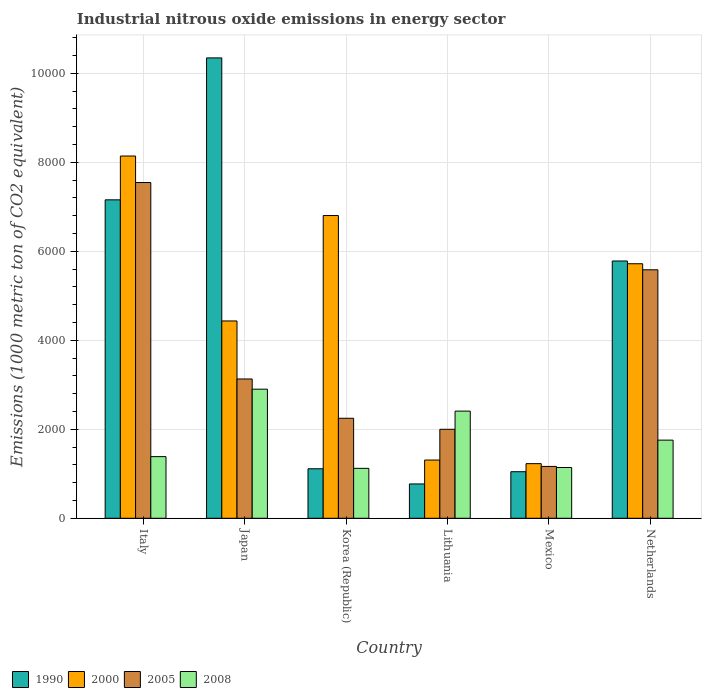How many different coloured bars are there?
Offer a very short reply. 4. Are the number of bars on each tick of the X-axis equal?
Offer a very short reply. Yes. What is the amount of industrial nitrous oxide emitted in 2008 in Japan?
Give a very brief answer. 2901. Across all countries, what is the maximum amount of industrial nitrous oxide emitted in 1990?
Provide a short and direct response. 1.03e+04. Across all countries, what is the minimum amount of industrial nitrous oxide emitted in 1990?
Keep it short and to the point. 771.2. In which country was the amount of industrial nitrous oxide emitted in 1990 minimum?
Your answer should be compact. Lithuania. What is the total amount of industrial nitrous oxide emitted in 2005 in the graph?
Make the answer very short. 2.17e+04. What is the difference between the amount of industrial nitrous oxide emitted in 2005 in Italy and that in Mexico?
Offer a very short reply. 6380.1. What is the difference between the amount of industrial nitrous oxide emitted in 2000 in Lithuania and the amount of industrial nitrous oxide emitted in 2008 in Korea (Republic)?
Offer a very short reply. 186.6. What is the average amount of industrial nitrous oxide emitted in 2000 per country?
Make the answer very short. 4605.48. What is the difference between the amount of industrial nitrous oxide emitted of/in 1990 and amount of industrial nitrous oxide emitted of/in 2005 in Netherlands?
Your answer should be compact. 197.9. What is the ratio of the amount of industrial nitrous oxide emitted in 2005 in Mexico to that in Netherlands?
Make the answer very short. 0.21. Is the amount of industrial nitrous oxide emitted in 2005 in Korea (Republic) less than that in Mexico?
Provide a short and direct response. No. Is the difference between the amount of industrial nitrous oxide emitted in 1990 in Korea (Republic) and Lithuania greater than the difference between the amount of industrial nitrous oxide emitted in 2005 in Korea (Republic) and Lithuania?
Ensure brevity in your answer.  Yes. What is the difference between the highest and the second highest amount of industrial nitrous oxide emitted in 2008?
Provide a succinct answer. 652.3. What is the difference between the highest and the lowest amount of industrial nitrous oxide emitted in 2005?
Your answer should be very brief. 6380.1. Is the sum of the amount of industrial nitrous oxide emitted in 2000 in Mexico and Netherlands greater than the maximum amount of industrial nitrous oxide emitted in 2008 across all countries?
Offer a very short reply. Yes. What is the difference between two consecutive major ticks on the Y-axis?
Provide a short and direct response. 2000. Are the values on the major ticks of Y-axis written in scientific E-notation?
Offer a very short reply. No. Where does the legend appear in the graph?
Keep it short and to the point. Bottom left. How are the legend labels stacked?
Provide a short and direct response. Horizontal. What is the title of the graph?
Make the answer very short. Industrial nitrous oxide emissions in energy sector. What is the label or title of the X-axis?
Your answer should be very brief. Country. What is the label or title of the Y-axis?
Keep it short and to the point. Emissions (1000 metric ton of CO2 equivalent). What is the Emissions (1000 metric ton of CO2 equivalent) in 1990 in Italy?
Ensure brevity in your answer.  7155.8. What is the Emissions (1000 metric ton of CO2 equivalent) in 2000 in Italy?
Offer a terse response. 8140.4. What is the Emissions (1000 metric ton of CO2 equivalent) in 2005 in Italy?
Your response must be concise. 7544.9. What is the Emissions (1000 metric ton of CO2 equivalent) in 2008 in Italy?
Provide a succinct answer. 1385.2. What is the Emissions (1000 metric ton of CO2 equivalent) in 1990 in Japan?
Keep it short and to the point. 1.03e+04. What is the Emissions (1000 metric ton of CO2 equivalent) in 2000 in Japan?
Keep it short and to the point. 4433.9. What is the Emissions (1000 metric ton of CO2 equivalent) in 2005 in Japan?
Keep it short and to the point. 3130.3. What is the Emissions (1000 metric ton of CO2 equivalent) in 2008 in Japan?
Provide a succinct answer. 2901. What is the Emissions (1000 metric ton of CO2 equivalent) of 1990 in Korea (Republic)?
Your response must be concise. 1112.3. What is the Emissions (1000 metric ton of CO2 equivalent) in 2000 in Korea (Republic)?
Your response must be concise. 6803. What is the Emissions (1000 metric ton of CO2 equivalent) of 2005 in Korea (Republic)?
Your answer should be very brief. 2247.5. What is the Emissions (1000 metric ton of CO2 equivalent) in 2008 in Korea (Republic)?
Provide a succinct answer. 1121.9. What is the Emissions (1000 metric ton of CO2 equivalent) of 1990 in Lithuania?
Give a very brief answer. 771.2. What is the Emissions (1000 metric ton of CO2 equivalent) of 2000 in Lithuania?
Make the answer very short. 1308.5. What is the Emissions (1000 metric ton of CO2 equivalent) of 2005 in Lithuania?
Ensure brevity in your answer.  1999.4. What is the Emissions (1000 metric ton of CO2 equivalent) in 2008 in Lithuania?
Provide a succinct answer. 2408. What is the Emissions (1000 metric ton of CO2 equivalent) of 1990 in Mexico?
Offer a very short reply. 1046.3. What is the Emissions (1000 metric ton of CO2 equivalent) in 2000 in Mexico?
Ensure brevity in your answer.  1227.6. What is the Emissions (1000 metric ton of CO2 equivalent) of 2005 in Mexico?
Your answer should be compact. 1164.8. What is the Emissions (1000 metric ton of CO2 equivalent) of 2008 in Mexico?
Your answer should be compact. 1141.1. What is the Emissions (1000 metric ton of CO2 equivalent) in 1990 in Netherlands?
Your answer should be very brief. 5781.5. What is the Emissions (1000 metric ton of CO2 equivalent) of 2000 in Netherlands?
Make the answer very short. 5719.5. What is the Emissions (1000 metric ton of CO2 equivalent) in 2005 in Netherlands?
Provide a short and direct response. 5583.6. What is the Emissions (1000 metric ton of CO2 equivalent) in 2008 in Netherlands?
Keep it short and to the point. 1755.7. Across all countries, what is the maximum Emissions (1000 metric ton of CO2 equivalent) in 1990?
Ensure brevity in your answer.  1.03e+04. Across all countries, what is the maximum Emissions (1000 metric ton of CO2 equivalent) of 2000?
Ensure brevity in your answer.  8140.4. Across all countries, what is the maximum Emissions (1000 metric ton of CO2 equivalent) of 2005?
Offer a terse response. 7544.9. Across all countries, what is the maximum Emissions (1000 metric ton of CO2 equivalent) in 2008?
Make the answer very short. 2901. Across all countries, what is the minimum Emissions (1000 metric ton of CO2 equivalent) in 1990?
Your response must be concise. 771.2. Across all countries, what is the minimum Emissions (1000 metric ton of CO2 equivalent) of 2000?
Provide a short and direct response. 1227.6. Across all countries, what is the minimum Emissions (1000 metric ton of CO2 equivalent) of 2005?
Keep it short and to the point. 1164.8. Across all countries, what is the minimum Emissions (1000 metric ton of CO2 equivalent) of 2008?
Your answer should be compact. 1121.9. What is the total Emissions (1000 metric ton of CO2 equivalent) of 1990 in the graph?
Give a very brief answer. 2.62e+04. What is the total Emissions (1000 metric ton of CO2 equivalent) in 2000 in the graph?
Your response must be concise. 2.76e+04. What is the total Emissions (1000 metric ton of CO2 equivalent) of 2005 in the graph?
Provide a short and direct response. 2.17e+04. What is the total Emissions (1000 metric ton of CO2 equivalent) of 2008 in the graph?
Your answer should be very brief. 1.07e+04. What is the difference between the Emissions (1000 metric ton of CO2 equivalent) in 1990 in Italy and that in Japan?
Ensure brevity in your answer.  -3189.6. What is the difference between the Emissions (1000 metric ton of CO2 equivalent) of 2000 in Italy and that in Japan?
Offer a very short reply. 3706.5. What is the difference between the Emissions (1000 metric ton of CO2 equivalent) of 2005 in Italy and that in Japan?
Your response must be concise. 4414.6. What is the difference between the Emissions (1000 metric ton of CO2 equivalent) in 2008 in Italy and that in Japan?
Your answer should be compact. -1515.8. What is the difference between the Emissions (1000 metric ton of CO2 equivalent) of 1990 in Italy and that in Korea (Republic)?
Your response must be concise. 6043.5. What is the difference between the Emissions (1000 metric ton of CO2 equivalent) in 2000 in Italy and that in Korea (Republic)?
Provide a short and direct response. 1337.4. What is the difference between the Emissions (1000 metric ton of CO2 equivalent) of 2005 in Italy and that in Korea (Republic)?
Your response must be concise. 5297.4. What is the difference between the Emissions (1000 metric ton of CO2 equivalent) of 2008 in Italy and that in Korea (Republic)?
Your answer should be compact. 263.3. What is the difference between the Emissions (1000 metric ton of CO2 equivalent) in 1990 in Italy and that in Lithuania?
Offer a very short reply. 6384.6. What is the difference between the Emissions (1000 metric ton of CO2 equivalent) of 2000 in Italy and that in Lithuania?
Your response must be concise. 6831.9. What is the difference between the Emissions (1000 metric ton of CO2 equivalent) of 2005 in Italy and that in Lithuania?
Offer a very short reply. 5545.5. What is the difference between the Emissions (1000 metric ton of CO2 equivalent) in 2008 in Italy and that in Lithuania?
Give a very brief answer. -1022.8. What is the difference between the Emissions (1000 metric ton of CO2 equivalent) in 1990 in Italy and that in Mexico?
Offer a very short reply. 6109.5. What is the difference between the Emissions (1000 metric ton of CO2 equivalent) in 2000 in Italy and that in Mexico?
Ensure brevity in your answer.  6912.8. What is the difference between the Emissions (1000 metric ton of CO2 equivalent) of 2005 in Italy and that in Mexico?
Your answer should be very brief. 6380.1. What is the difference between the Emissions (1000 metric ton of CO2 equivalent) of 2008 in Italy and that in Mexico?
Offer a terse response. 244.1. What is the difference between the Emissions (1000 metric ton of CO2 equivalent) in 1990 in Italy and that in Netherlands?
Make the answer very short. 1374.3. What is the difference between the Emissions (1000 metric ton of CO2 equivalent) in 2000 in Italy and that in Netherlands?
Your answer should be very brief. 2420.9. What is the difference between the Emissions (1000 metric ton of CO2 equivalent) in 2005 in Italy and that in Netherlands?
Keep it short and to the point. 1961.3. What is the difference between the Emissions (1000 metric ton of CO2 equivalent) of 2008 in Italy and that in Netherlands?
Provide a succinct answer. -370.5. What is the difference between the Emissions (1000 metric ton of CO2 equivalent) of 1990 in Japan and that in Korea (Republic)?
Your response must be concise. 9233.1. What is the difference between the Emissions (1000 metric ton of CO2 equivalent) in 2000 in Japan and that in Korea (Republic)?
Keep it short and to the point. -2369.1. What is the difference between the Emissions (1000 metric ton of CO2 equivalent) of 2005 in Japan and that in Korea (Republic)?
Provide a succinct answer. 882.8. What is the difference between the Emissions (1000 metric ton of CO2 equivalent) of 2008 in Japan and that in Korea (Republic)?
Your answer should be very brief. 1779.1. What is the difference between the Emissions (1000 metric ton of CO2 equivalent) in 1990 in Japan and that in Lithuania?
Your response must be concise. 9574.2. What is the difference between the Emissions (1000 metric ton of CO2 equivalent) in 2000 in Japan and that in Lithuania?
Provide a short and direct response. 3125.4. What is the difference between the Emissions (1000 metric ton of CO2 equivalent) of 2005 in Japan and that in Lithuania?
Keep it short and to the point. 1130.9. What is the difference between the Emissions (1000 metric ton of CO2 equivalent) of 2008 in Japan and that in Lithuania?
Keep it short and to the point. 493. What is the difference between the Emissions (1000 metric ton of CO2 equivalent) in 1990 in Japan and that in Mexico?
Offer a terse response. 9299.1. What is the difference between the Emissions (1000 metric ton of CO2 equivalent) of 2000 in Japan and that in Mexico?
Your answer should be very brief. 3206.3. What is the difference between the Emissions (1000 metric ton of CO2 equivalent) of 2005 in Japan and that in Mexico?
Ensure brevity in your answer.  1965.5. What is the difference between the Emissions (1000 metric ton of CO2 equivalent) of 2008 in Japan and that in Mexico?
Offer a very short reply. 1759.9. What is the difference between the Emissions (1000 metric ton of CO2 equivalent) in 1990 in Japan and that in Netherlands?
Keep it short and to the point. 4563.9. What is the difference between the Emissions (1000 metric ton of CO2 equivalent) in 2000 in Japan and that in Netherlands?
Offer a very short reply. -1285.6. What is the difference between the Emissions (1000 metric ton of CO2 equivalent) in 2005 in Japan and that in Netherlands?
Provide a short and direct response. -2453.3. What is the difference between the Emissions (1000 metric ton of CO2 equivalent) in 2008 in Japan and that in Netherlands?
Keep it short and to the point. 1145.3. What is the difference between the Emissions (1000 metric ton of CO2 equivalent) in 1990 in Korea (Republic) and that in Lithuania?
Your response must be concise. 341.1. What is the difference between the Emissions (1000 metric ton of CO2 equivalent) of 2000 in Korea (Republic) and that in Lithuania?
Your response must be concise. 5494.5. What is the difference between the Emissions (1000 metric ton of CO2 equivalent) of 2005 in Korea (Republic) and that in Lithuania?
Offer a terse response. 248.1. What is the difference between the Emissions (1000 metric ton of CO2 equivalent) of 2008 in Korea (Republic) and that in Lithuania?
Offer a very short reply. -1286.1. What is the difference between the Emissions (1000 metric ton of CO2 equivalent) of 1990 in Korea (Republic) and that in Mexico?
Give a very brief answer. 66. What is the difference between the Emissions (1000 metric ton of CO2 equivalent) in 2000 in Korea (Republic) and that in Mexico?
Give a very brief answer. 5575.4. What is the difference between the Emissions (1000 metric ton of CO2 equivalent) of 2005 in Korea (Republic) and that in Mexico?
Your answer should be very brief. 1082.7. What is the difference between the Emissions (1000 metric ton of CO2 equivalent) of 2008 in Korea (Republic) and that in Mexico?
Offer a terse response. -19.2. What is the difference between the Emissions (1000 metric ton of CO2 equivalent) in 1990 in Korea (Republic) and that in Netherlands?
Make the answer very short. -4669.2. What is the difference between the Emissions (1000 metric ton of CO2 equivalent) in 2000 in Korea (Republic) and that in Netherlands?
Your answer should be very brief. 1083.5. What is the difference between the Emissions (1000 metric ton of CO2 equivalent) of 2005 in Korea (Republic) and that in Netherlands?
Your response must be concise. -3336.1. What is the difference between the Emissions (1000 metric ton of CO2 equivalent) in 2008 in Korea (Republic) and that in Netherlands?
Offer a very short reply. -633.8. What is the difference between the Emissions (1000 metric ton of CO2 equivalent) in 1990 in Lithuania and that in Mexico?
Your response must be concise. -275.1. What is the difference between the Emissions (1000 metric ton of CO2 equivalent) in 2000 in Lithuania and that in Mexico?
Make the answer very short. 80.9. What is the difference between the Emissions (1000 metric ton of CO2 equivalent) in 2005 in Lithuania and that in Mexico?
Offer a terse response. 834.6. What is the difference between the Emissions (1000 metric ton of CO2 equivalent) in 2008 in Lithuania and that in Mexico?
Offer a terse response. 1266.9. What is the difference between the Emissions (1000 metric ton of CO2 equivalent) in 1990 in Lithuania and that in Netherlands?
Make the answer very short. -5010.3. What is the difference between the Emissions (1000 metric ton of CO2 equivalent) of 2000 in Lithuania and that in Netherlands?
Keep it short and to the point. -4411. What is the difference between the Emissions (1000 metric ton of CO2 equivalent) of 2005 in Lithuania and that in Netherlands?
Your answer should be very brief. -3584.2. What is the difference between the Emissions (1000 metric ton of CO2 equivalent) of 2008 in Lithuania and that in Netherlands?
Keep it short and to the point. 652.3. What is the difference between the Emissions (1000 metric ton of CO2 equivalent) in 1990 in Mexico and that in Netherlands?
Offer a very short reply. -4735.2. What is the difference between the Emissions (1000 metric ton of CO2 equivalent) in 2000 in Mexico and that in Netherlands?
Provide a short and direct response. -4491.9. What is the difference between the Emissions (1000 metric ton of CO2 equivalent) of 2005 in Mexico and that in Netherlands?
Provide a succinct answer. -4418.8. What is the difference between the Emissions (1000 metric ton of CO2 equivalent) of 2008 in Mexico and that in Netherlands?
Provide a short and direct response. -614.6. What is the difference between the Emissions (1000 metric ton of CO2 equivalent) in 1990 in Italy and the Emissions (1000 metric ton of CO2 equivalent) in 2000 in Japan?
Your response must be concise. 2721.9. What is the difference between the Emissions (1000 metric ton of CO2 equivalent) of 1990 in Italy and the Emissions (1000 metric ton of CO2 equivalent) of 2005 in Japan?
Give a very brief answer. 4025.5. What is the difference between the Emissions (1000 metric ton of CO2 equivalent) of 1990 in Italy and the Emissions (1000 metric ton of CO2 equivalent) of 2008 in Japan?
Provide a succinct answer. 4254.8. What is the difference between the Emissions (1000 metric ton of CO2 equivalent) in 2000 in Italy and the Emissions (1000 metric ton of CO2 equivalent) in 2005 in Japan?
Make the answer very short. 5010.1. What is the difference between the Emissions (1000 metric ton of CO2 equivalent) of 2000 in Italy and the Emissions (1000 metric ton of CO2 equivalent) of 2008 in Japan?
Offer a very short reply. 5239.4. What is the difference between the Emissions (1000 metric ton of CO2 equivalent) of 2005 in Italy and the Emissions (1000 metric ton of CO2 equivalent) of 2008 in Japan?
Offer a terse response. 4643.9. What is the difference between the Emissions (1000 metric ton of CO2 equivalent) in 1990 in Italy and the Emissions (1000 metric ton of CO2 equivalent) in 2000 in Korea (Republic)?
Offer a very short reply. 352.8. What is the difference between the Emissions (1000 metric ton of CO2 equivalent) in 1990 in Italy and the Emissions (1000 metric ton of CO2 equivalent) in 2005 in Korea (Republic)?
Keep it short and to the point. 4908.3. What is the difference between the Emissions (1000 metric ton of CO2 equivalent) in 1990 in Italy and the Emissions (1000 metric ton of CO2 equivalent) in 2008 in Korea (Republic)?
Give a very brief answer. 6033.9. What is the difference between the Emissions (1000 metric ton of CO2 equivalent) of 2000 in Italy and the Emissions (1000 metric ton of CO2 equivalent) of 2005 in Korea (Republic)?
Your answer should be very brief. 5892.9. What is the difference between the Emissions (1000 metric ton of CO2 equivalent) in 2000 in Italy and the Emissions (1000 metric ton of CO2 equivalent) in 2008 in Korea (Republic)?
Offer a very short reply. 7018.5. What is the difference between the Emissions (1000 metric ton of CO2 equivalent) of 2005 in Italy and the Emissions (1000 metric ton of CO2 equivalent) of 2008 in Korea (Republic)?
Provide a short and direct response. 6423. What is the difference between the Emissions (1000 metric ton of CO2 equivalent) in 1990 in Italy and the Emissions (1000 metric ton of CO2 equivalent) in 2000 in Lithuania?
Offer a very short reply. 5847.3. What is the difference between the Emissions (1000 metric ton of CO2 equivalent) in 1990 in Italy and the Emissions (1000 metric ton of CO2 equivalent) in 2005 in Lithuania?
Make the answer very short. 5156.4. What is the difference between the Emissions (1000 metric ton of CO2 equivalent) in 1990 in Italy and the Emissions (1000 metric ton of CO2 equivalent) in 2008 in Lithuania?
Keep it short and to the point. 4747.8. What is the difference between the Emissions (1000 metric ton of CO2 equivalent) of 2000 in Italy and the Emissions (1000 metric ton of CO2 equivalent) of 2005 in Lithuania?
Provide a succinct answer. 6141. What is the difference between the Emissions (1000 metric ton of CO2 equivalent) of 2000 in Italy and the Emissions (1000 metric ton of CO2 equivalent) of 2008 in Lithuania?
Provide a succinct answer. 5732.4. What is the difference between the Emissions (1000 metric ton of CO2 equivalent) in 2005 in Italy and the Emissions (1000 metric ton of CO2 equivalent) in 2008 in Lithuania?
Give a very brief answer. 5136.9. What is the difference between the Emissions (1000 metric ton of CO2 equivalent) in 1990 in Italy and the Emissions (1000 metric ton of CO2 equivalent) in 2000 in Mexico?
Your response must be concise. 5928.2. What is the difference between the Emissions (1000 metric ton of CO2 equivalent) in 1990 in Italy and the Emissions (1000 metric ton of CO2 equivalent) in 2005 in Mexico?
Keep it short and to the point. 5991. What is the difference between the Emissions (1000 metric ton of CO2 equivalent) of 1990 in Italy and the Emissions (1000 metric ton of CO2 equivalent) of 2008 in Mexico?
Your answer should be compact. 6014.7. What is the difference between the Emissions (1000 metric ton of CO2 equivalent) in 2000 in Italy and the Emissions (1000 metric ton of CO2 equivalent) in 2005 in Mexico?
Give a very brief answer. 6975.6. What is the difference between the Emissions (1000 metric ton of CO2 equivalent) in 2000 in Italy and the Emissions (1000 metric ton of CO2 equivalent) in 2008 in Mexico?
Your answer should be compact. 6999.3. What is the difference between the Emissions (1000 metric ton of CO2 equivalent) in 2005 in Italy and the Emissions (1000 metric ton of CO2 equivalent) in 2008 in Mexico?
Your response must be concise. 6403.8. What is the difference between the Emissions (1000 metric ton of CO2 equivalent) in 1990 in Italy and the Emissions (1000 metric ton of CO2 equivalent) in 2000 in Netherlands?
Keep it short and to the point. 1436.3. What is the difference between the Emissions (1000 metric ton of CO2 equivalent) of 1990 in Italy and the Emissions (1000 metric ton of CO2 equivalent) of 2005 in Netherlands?
Ensure brevity in your answer.  1572.2. What is the difference between the Emissions (1000 metric ton of CO2 equivalent) of 1990 in Italy and the Emissions (1000 metric ton of CO2 equivalent) of 2008 in Netherlands?
Provide a succinct answer. 5400.1. What is the difference between the Emissions (1000 metric ton of CO2 equivalent) in 2000 in Italy and the Emissions (1000 metric ton of CO2 equivalent) in 2005 in Netherlands?
Make the answer very short. 2556.8. What is the difference between the Emissions (1000 metric ton of CO2 equivalent) in 2000 in Italy and the Emissions (1000 metric ton of CO2 equivalent) in 2008 in Netherlands?
Your response must be concise. 6384.7. What is the difference between the Emissions (1000 metric ton of CO2 equivalent) of 2005 in Italy and the Emissions (1000 metric ton of CO2 equivalent) of 2008 in Netherlands?
Ensure brevity in your answer.  5789.2. What is the difference between the Emissions (1000 metric ton of CO2 equivalent) in 1990 in Japan and the Emissions (1000 metric ton of CO2 equivalent) in 2000 in Korea (Republic)?
Give a very brief answer. 3542.4. What is the difference between the Emissions (1000 metric ton of CO2 equivalent) in 1990 in Japan and the Emissions (1000 metric ton of CO2 equivalent) in 2005 in Korea (Republic)?
Provide a succinct answer. 8097.9. What is the difference between the Emissions (1000 metric ton of CO2 equivalent) of 1990 in Japan and the Emissions (1000 metric ton of CO2 equivalent) of 2008 in Korea (Republic)?
Make the answer very short. 9223.5. What is the difference between the Emissions (1000 metric ton of CO2 equivalent) in 2000 in Japan and the Emissions (1000 metric ton of CO2 equivalent) in 2005 in Korea (Republic)?
Offer a terse response. 2186.4. What is the difference between the Emissions (1000 metric ton of CO2 equivalent) of 2000 in Japan and the Emissions (1000 metric ton of CO2 equivalent) of 2008 in Korea (Republic)?
Give a very brief answer. 3312. What is the difference between the Emissions (1000 metric ton of CO2 equivalent) of 2005 in Japan and the Emissions (1000 metric ton of CO2 equivalent) of 2008 in Korea (Republic)?
Provide a succinct answer. 2008.4. What is the difference between the Emissions (1000 metric ton of CO2 equivalent) of 1990 in Japan and the Emissions (1000 metric ton of CO2 equivalent) of 2000 in Lithuania?
Your answer should be compact. 9036.9. What is the difference between the Emissions (1000 metric ton of CO2 equivalent) in 1990 in Japan and the Emissions (1000 metric ton of CO2 equivalent) in 2005 in Lithuania?
Ensure brevity in your answer.  8346. What is the difference between the Emissions (1000 metric ton of CO2 equivalent) in 1990 in Japan and the Emissions (1000 metric ton of CO2 equivalent) in 2008 in Lithuania?
Your answer should be compact. 7937.4. What is the difference between the Emissions (1000 metric ton of CO2 equivalent) of 2000 in Japan and the Emissions (1000 metric ton of CO2 equivalent) of 2005 in Lithuania?
Your response must be concise. 2434.5. What is the difference between the Emissions (1000 metric ton of CO2 equivalent) in 2000 in Japan and the Emissions (1000 metric ton of CO2 equivalent) in 2008 in Lithuania?
Provide a short and direct response. 2025.9. What is the difference between the Emissions (1000 metric ton of CO2 equivalent) in 2005 in Japan and the Emissions (1000 metric ton of CO2 equivalent) in 2008 in Lithuania?
Provide a short and direct response. 722.3. What is the difference between the Emissions (1000 metric ton of CO2 equivalent) of 1990 in Japan and the Emissions (1000 metric ton of CO2 equivalent) of 2000 in Mexico?
Provide a short and direct response. 9117.8. What is the difference between the Emissions (1000 metric ton of CO2 equivalent) of 1990 in Japan and the Emissions (1000 metric ton of CO2 equivalent) of 2005 in Mexico?
Your answer should be compact. 9180.6. What is the difference between the Emissions (1000 metric ton of CO2 equivalent) in 1990 in Japan and the Emissions (1000 metric ton of CO2 equivalent) in 2008 in Mexico?
Offer a terse response. 9204.3. What is the difference between the Emissions (1000 metric ton of CO2 equivalent) in 2000 in Japan and the Emissions (1000 metric ton of CO2 equivalent) in 2005 in Mexico?
Make the answer very short. 3269.1. What is the difference between the Emissions (1000 metric ton of CO2 equivalent) in 2000 in Japan and the Emissions (1000 metric ton of CO2 equivalent) in 2008 in Mexico?
Make the answer very short. 3292.8. What is the difference between the Emissions (1000 metric ton of CO2 equivalent) of 2005 in Japan and the Emissions (1000 metric ton of CO2 equivalent) of 2008 in Mexico?
Your answer should be very brief. 1989.2. What is the difference between the Emissions (1000 metric ton of CO2 equivalent) of 1990 in Japan and the Emissions (1000 metric ton of CO2 equivalent) of 2000 in Netherlands?
Your answer should be compact. 4625.9. What is the difference between the Emissions (1000 metric ton of CO2 equivalent) of 1990 in Japan and the Emissions (1000 metric ton of CO2 equivalent) of 2005 in Netherlands?
Provide a succinct answer. 4761.8. What is the difference between the Emissions (1000 metric ton of CO2 equivalent) of 1990 in Japan and the Emissions (1000 metric ton of CO2 equivalent) of 2008 in Netherlands?
Provide a short and direct response. 8589.7. What is the difference between the Emissions (1000 metric ton of CO2 equivalent) in 2000 in Japan and the Emissions (1000 metric ton of CO2 equivalent) in 2005 in Netherlands?
Provide a succinct answer. -1149.7. What is the difference between the Emissions (1000 metric ton of CO2 equivalent) of 2000 in Japan and the Emissions (1000 metric ton of CO2 equivalent) of 2008 in Netherlands?
Keep it short and to the point. 2678.2. What is the difference between the Emissions (1000 metric ton of CO2 equivalent) in 2005 in Japan and the Emissions (1000 metric ton of CO2 equivalent) in 2008 in Netherlands?
Provide a short and direct response. 1374.6. What is the difference between the Emissions (1000 metric ton of CO2 equivalent) in 1990 in Korea (Republic) and the Emissions (1000 metric ton of CO2 equivalent) in 2000 in Lithuania?
Make the answer very short. -196.2. What is the difference between the Emissions (1000 metric ton of CO2 equivalent) in 1990 in Korea (Republic) and the Emissions (1000 metric ton of CO2 equivalent) in 2005 in Lithuania?
Make the answer very short. -887.1. What is the difference between the Emissions (1000 metric ton of CO2 equivalent) of 1990 in Korea (Republic) and the Emissions (1000 metric ton of CO2 equivalent) of 2008 in Lithuania?
Offer a terse response. -1295.7. What is the difference between the Emissions (1000 metric ton of CO2 equivalent) of 2000 in Korea (Republic) and the Emissions (1000 metric ton of CO2 equivalent) of 2005 in Lithuania?
Offer a terse response. 4803.6. What is the difference between the Emissions (1000 metric ton of CO2 equivalent) of 2000 in Korea (Republic) and the Emissions (1000 metric ton of CO2 equivalent) of 2008 in Lithuania?
Provide a succinct answer. 4395. What is the difference between the Emissions (1000 metric ton of CO2 equivalent) of 2005 in Korea (Republic) and the Emissions (1000 metric ton of CO2 equivalent) of 2008 in Lithuania?
Your response must be concise. -160.5. What is the difference between the Emissions (1000 metric ton of CO2 equivalent) in 1990 in Korea (Republic) and the Emissions (1000 metric ton of CO2 equivalent) in 2000 in Mexico?
Offer a terse response. -115.3. What is the difference between the Emissions (1000 metric ton of CO2 equivalent) in 1990 in Korea (Republic) and the Emissions (1000 metric ton of CO2 equivalent) in 2005 in Mexico?
Offer a very short reply. -52.5. What is the difference between the Emissions (1000 metric ton of CO2 equivalent) in 1990 in Korea (Republic) and the Emissions (1000 metric ton of CO2 equivalent) in 2008 in Mexico?
Your answer should be compact. -28.8. What is the difference between the Emissions (1000 metric ton of CO2 equivalent) of 2000 in Korea (Republic) and the Emissions (1000 metric ton of CO2 equivalent) of 2005 in Mexico?
Your answer should be very brief. 5638.2. What is the difference between the Emissions (1000 metric ton of CO2 equivalent) of 2000 in Korea (Republic) and the Emissions (1000 metric ton of CO2 equivalent) of 2008 in Mexico?
Your answer should be compact. 5661.9. What is the difference between the Emissions (1000 metric ton of CO2 equivalent) in 2005 in Korea (Republic) and the Emissions (1000 metric ton of CO2 equivalent) in 2008 in Mexico?
Ensure brevity in your answer.  1106.4. What is the difference between the Emissions (1000 metric ton of CO2 equivalent) of 1990 in Korea (Republic) and the Emissions (1000 metric ton of CO2 equivalent) of 2000 in Netherlands?
Your response must be concise. -4607.2. What is the difference between the Emissions (1000 metric ton of CO2 equivalent) of 1990 in Korea (Republic) and the Emissions (1000 metric ton of CO2 equivalent) of 2005 in Netherlands?
Provide a short and direct response. -4471.3. What is the difference between the Emissions (1000 metric ton of CO2 equivalent) in 1990 in Korea (Republic) and the Emissions (1000 metric ton of CO2 equivalent) in 2008 in Netherlands?
Your answer should be compact. -643.4. What is the difference between the Emissions (1000 metric ton of CO2 equivalent) of 2000 in Korea (Republic) and the Emissions (1000 metric ton of CO2 equivalent) of 2005 in Netherlands?
Give a very brief answer. 1219.4. What is the difference between the Emissions (1000 metric ton of CO2 equivalent) of 2000 in Korea (Republic) and the Emissions (1000 metric ton of CO2 equivalent) of 2008 in Netherlands?
Your answer should be compact. 5047.3. What is the difference between the Emissions (1000 metric ton of CO2 equivalent) of 2005 in Korea (Republic) and the Emissions (1000 metric ton of CO2 equivalent) of 2008 in Netherlands?
Ensure brevity in your answer.  491.8. What is the difference between the Emissions (1000 metric ton of CO2 equivalent) of 1990 in Lithuania and the Emissions (1000 metric ton of CO2 equivalent) of 2000 in Mexico?
Ensure brevity in your answer.  -456.4. What is the difference between the Emissions (1000 metric ton of CO2 equivalent) of 1990 in Lithuania and the Emissions (1000 metric ton of CO2 equivalent) of 2005 in Mexico?
Offer a terse response. -393.6. What is the difference between the Emissions (1000 metric ton of CO2 equivalent) in 1990 in Lithuania and the Emissions (1000 metric ton of CO2 equivalent) in 2008 in Mexico?
Your answer should be compact. -369.9. What is the difference between the Emissions (1000 metric ton of CO2 equivalent) of 2000 in Lithuania and the Emissions (1000 metric ton of CO2 equivalent) of 2005 in Mexico?
Make the answer very short. 143.7. What is the difference between the Emissions (1000 metric ton of CO2 equivalent) of 2000 in Lithuania and the Emissions (1000 metric ton of CO2 equivalent) of 2008 in Mexico?
Offer a very short reply. 167.4. What is the difference between the Emissions (1000 metric ton of CO2 equivalent) in 2005 in Lithuania and the Emissions (1000 metric ton of CO2 equivalent) in 2008 in Mexico?
Your answer should be very brief. 858.3. What is the difference between the Emissions (1000 metric ton of CO2 equivalent) in 1990 in Lithuania and the Emissions (1000 metric ton of CO2 equivalent) in 2000 in Netherlands?
Your answer should be very brief. -4948.3. What is the difference between the Emissions (1000 metric ton of CO2 equivalent) in 1990 in Lithuania and the Emissions (1000 metric ton of CO2 equivalent) in 2005 in Netherlands?
Your response must be concise. -4812.4. What is the difference between the Emissions (1000 metric ton of CO2 equivalent) of 1990 in Lithuania and the Emissions (1000 metric ton of CO2 equivalent) of 2008 in Netherlands?
Offer a terse response. -984.5. What is the difference between the Emissions (1000 metric ton of CO2 equivalent) of 2000 in Lithuania and the Emissions (1000 metric ton of CO2 equivalent) of 2005 in Netherlands?
Give a very brief answer. -4275.1. What is the difference between the Emissions (1000 metric ton of CO2 equivalent) in 2000 in Lithuania and the Emissions (1000 metric ton of CO2 equivalent) in 2008 in Netherlands?
Your answer should be compact. -447.2. What is the difference between the Emissions (1000 metric ton of CO2 equivalent) of 2005 in Lithuania and the Emissions (1000 metric ton of CO2 equivalent) of 2008 in Netherlands?
Your answer should be compact. 243.7. What is the difference between the Emissions (1000 metric ton of CO2 equivalent) of 1990 in Mexico and the Emissions (1000 metric ton of CO2 equivalent) of 2000 in Netherlands?
Your answer should be compact. -4673.2. What is the difference between the Emissions (1000 metric ton of CO2 equivalent) in 1990 in Mexico and the Emissions (1000 metric ton of CO2 equivalent) in 2005 in Netherlands?
Provide a short and direct response. -4537.3. What is the difference between the Emissions (1000 metric ton of CO2 equivalent) of 1990 in Mexico and the Emissions (1000 metric ton of CO2 equivalent) of 2008 in Netherlands?
Make the answer very short. -709.4. What is the difference between the Emissions (1000 metric ton of CO2 equivalent) of 2000 in Mexico and the Emissions (1000 metric ton of CO2 equivalent) of 2005 in Netherlands?
Keep it short and to the point. -4356. What is the difference between the Emissions (1000 metric ton of CO2 equivalent) of 2000 in Mexico and the Emissions (1000 metric ton of CO2 equivalent) of 2008 in Netherlands?
Keep it short and to the point. -528.1. What is the difference between the Emissions (1000 metric ton of CO2 equivalent) of 2005 in Mexico and the Emissions (1000 metric ton of CO2 equivalent) of 2008 in Netherlands?
Your response must be concise. -590.9. What is the average Emissions (1000 metric ton of CO2 equivalent) in 1990 per country?
Provide a succinct answer. 4368.75. What is the average Emissions (1000 metric ton of CO2 equivalent) in 2000 per country?
Your answer should be very brief. 4605.48. What is the average Emissions (1000 metric ton of CO2 equivalent) of 2005 per country?
Your answer should be very brief. 3611.75. What is the average Emissions (1000 metric ton of CO2 equivalent) of 2008 per country?
Make the answer very short. 1785.48. What is the difference between the Emissions (1000 metric ton of CO2 equivalent) of 1990 and Emissions (1000 metric ton of CO2 equivalent) of 2000 in Italy?
Give a very brief answer. -984.6. What is the difference between the Emissions (1000 metric ton of CO2 equivalent) in 1990 and Emissions (1000 metric ton of CO2 equivalent) in 2005 in Italy?
Your answer should be compact. -389.1. What is the difference between the Emissions (1000 metric ton of CO2 equivalent) in 1990 and Emissions (1000 metric ton of CO2 equivalent) in 2008 in Italy?
Your answer should be very brief. 5770.6. What is the difference between the Emissions (1000 metric ton of CO2 equivalent) in 2000 and Emissions (1000 metric ton of CO2 equivalent) in 2005 in Italy?
Provide a succinct answer. 595.5. What is the difference between the Emissions (1000 metric ton of CO2 equivalent) of 2000 and Emissions (1000 metric ton of CO2 equivalent) of 2008 in Italy?
Your answer should be compact. 6755.2. What is the difference between the Emissions (1000 metric ton of CO2 equivalent) in 2005 and Emissions (1000 metric ton of CO2 equivalent) in 2008 in Italy?
Provide a short and direct response. 6159.7. What is the difference between the Emissions (1000 metric ton of CO2 equivalent) of 1990 and Emissions (1000 metric ton of CO2 equivalent) of 2000 in Japan?
Your answer should be compact. 5911.5. What is the difference between the Emissions (1000 metric ton of CO2 equivalent) of 1990 and Emissions (1000 metric ton of CO2 equivalent) of 2005 in Japan?
Your response must be concise. 7215.1. What is the difference between the Emissions (1000 metric ton of CO2 equivalent) in 1990 and Emissions (1000 metric ton of CO2 equivalent) in 2008 in Japan?
Offer a terse response. 7444.4. What is the difference between the Emissions (1000 metric ton of CO2 equivalent) of 2000 and Emissions (1000 metric ton of CO2 equivalent) of 2005 in Japan?
Offer a terse response. 1303.6. What is the difference between the Emissions (1000 metric ton of CO2 equivalent) in 2000 and Emissions (1000 metric ton of CO2 equivalent) in 2008 in Japan?
Provide a short and direct response. 1532.9. What is the difference between the Emissions (1000 metric ton of CO2 equivalent) of 2005 and Emissions (1000 metric ton of CO2 equivalent) of 2008 in Japan?
Make the answer very short. 229.3. What is the difference between the Emissions (1000 metric ton of CO2 equivalent) of 1990 and Emissions (1000 metric ton of CO2 equivalent) of 2000 in Korea (Republic)?
Give a very brief answer. -5690.7. What is the difference between the Emissions (1000 metric ton of CO2 equivalent) of 1990 and Emissions (1000 metric ton of CO2 equivalent) of 2005 in Korea (Republic)?
Offer a very short reply. -1135.2. What is the difference between the Emissions (1000 metric ton of CO2 equivalent) of 1990 and Emissions (1000 metric ton of CO2 equivalent) of 2008 in Korea (Republic)?
Keep it short and to the point. -9.6. What is the difference between the Emissions (1000 metric ton of CO2 equivalent) of 2000 and Emissions (1000 metric ton of CO2 equivalent) of 2005 in Korea (Republic)?
Your response must be concise. 4555.5. What is the difference between the Emissions (1000 metric ton of CO2 equivalent) in 2000 and Emissions (1000 metric ton of CO2 equivalent) in 2008 in Korea (Republic)?
Your response must be concise. 5681.1. What is the difference between the Emissions (1000 metric ton of CO2 equivalent) of 2005 and Emissions (1000 metric ton of CO2 equivalent) of 2008 in Korea (Republic)?
Provide a succinct answer. 1125.6. What is the difference between the Emissions (1000 metric ton of CO2 equivalent) of 1990 and Emissions (1000 metric ton of CO2 equivalent) of 2000 in Lithuania?
Your response must be concise. -537.3. What is the difference between the Emissions (1000 metric ton of CO2 equivalent) in 1990 and Emissions (1000 metric ton of CO2 equivalent) in 2005 in Lithuania?
Make the answer very short. -1228.2. What is the difference between the Emissions (1000 metric ton of CO2 equivalent) of 1990 and Emissions (1000 metric ton of CO2 equivalent) of 2008 in Lithuania?
Your response must be concise. -1636.8. What is the difference between the Emissions (1000 metric ton of CO2 equivalent) of 2000 and Emissions (1000 metric ton of CO2 equivalent) of 2005 in Lithuania?
Your response must be concise. -690.9. What is the difference between the Emissions (1000 metric ton of CO2 equivalent) in 2000 and Emissions (1000 metric ton of CO2 equivalent) in 2008 in Lithuania?
Your answer should be very brief. -1099.5. What is the difference between the Emissions (1000 metric ton of CO2 equivalent) in 2005 and Emissions (1000 metric ton of CO2 equivalent) in 2008 in Lithuania?
Offer a terse response. -408.6. What is the difference between the Emissions (1000 metric ton of CO2 equivalent) in 1990 and Emissions (1000 metric ton of CO2 equivalent) in 2000 in Mexico?
Offer a very short reply. -181.3. What is the difference between the Emissions (1000 metric ton of CO2 equivalent) in 1990 and Emissions (1000 metric ton of CO2 equivalent) in 2005 in Mexico?
Your response must be concise. -118.5. What is the difference between the Emissions (1000 metric ton of CO2 equivalent) of 1990 and Emissions (1000 metric ton of CO2 equivalent) of 2008 in Mexico?
Provide a short and direct response. -94.8. What is the difference between the Emissions (1000 metric ton of CO2 equivalent) in 2000 and Emissions (1000 metric ton of CO2 equivalent) in 2005 in Mexico?
Keep it short and to the point. 62.8. What is the difference between the Emissions (1000 metric ton of CO2 equivalent) of 2000 and Emissions (1000 metric ton of CO2 equivalent) of 2008 in Mexico?
Offer a terse response. 86.5. What is the difference between the Emissions (1000 metric ton of CO2 equivalent) of 2005 and Emissions (1000 metric ton of CO2 equivalent) of 2008 in Mexico?
Your answer should be compact. 23.7. What is the difference between the Emissions (1000 metric ton of CO2 equivalent) in 1990 and Emissions (1000 metric ton of CO2 equivalent) in 2005 in Netherlands?
Offer a very short reply. 197.9. What is the difference between the Emissions (1000 metric ton of CO2 equivalent) of 1990 and Emissions (1000 metric ton of CO2 equivalent) of 2008 in Netherlands?
Your answer should be very brief. 4025.8. What is the difference between the Emissions (1000 metric ton of CO2 equivalent) in 2000 and Emissions (1000 metric ton of CO2 equivalent) in 2005 in Netherlands?
Make the answer very short. 135.9. What is the difference between the Emissions (1000 metric ton of CO2 equivalent) in 2000 and Emissions (1000 metric ton of CO2 equivalent) in 2008 in Netherlands?
Give a very brief answer. 3963.8. What is the difference between the Emissions (1000 metric ton of CO2 equivalent) in 2005 and Emissions (1000 metric ton of CO2 equivalent) in 2008 in Netherlands?
Keep it short and to the point. 3827.9. What is the ratio of the Emissions (1000 metric ton of CO2 equivalent) in 1990 in Italy to that in Japan?
Provide a short and direct response. 0.69. What is the ratio of the Emissions (1000 metric ton of CO2 equivalent) of 2000 in Italy to that in Japan?
Make the answer very short. 1.84. What is the ratio of the Emissions (1000 metric ton of CO2 equivalent) in 2005 in Italy to that in Japan?
Provide a short and direct response. 2.41. What is the ratio of the Emissions (1000 metric ton of CO2 equivalent) of 2008 in Italy to that in Japan?
Ensure brevity in your answer.  0.48. What is the ratio of the Emissions (1000 metric ton of CO2 equivalent) in 1990 in Italy to that in Korea (Republic)?
Keep it short and to the point. 6.43. What is the ratio of the Emissions (1000 metric ton of CO2 equivalent) in 2000 in Italy to that in Korea (Republic)?
Make the answer very short. 1.2. What is the ratio of the Emissions (1000 metric ton of CO2 equivalent) in 2005 in Italy to that in Korea (Republic)?
Your answer should be compact. 3.36. What is the ratio of the Emissions (1000 metric ton of CO2 equivalent) of 2008 in Italy to that in Korea (Republic)?
Give a very brief answer. 1.23. What is the ratio of the Emissions (1000 metric ton of CO2 equivalent) of 1990 in Italy to that in Lithuania?
Offer a terse response. 9.28. What is the ratio of the Emissions (1000 metric ton of CO2 equivalent) of 2000 in Italy to that in Lithuania?
Make the answer very short. 6.22. What is the ratio of the Emissions (1000 metric ton of CO2 equivalent) in 2005 in Italy to that in Lithuania?
Provide a short and direct response. 3.77. What is the ratio of the Emissions (1000 metric ton of CO2 equivalent) of 2008 in Italy to that in Lithuania?
Offer a very short reply. 0.58. What is the ratio of the Emissions (1000 metric ton of CO2 equivalent) of 1990 in Italy to that in Mexico?
Provide a short and direct response. 6.84. What is the ratio of the Emissions (1000 metric ton of CO2 equivalent) of 2000 in Italy to that in Mexico?
Provide a succinct answer. 6.63. What is the ratio of the Emissions (1000 metric ton of CO2 equivalent) of 2005 in Italy to that in Mexico?
Ensure brevity in your answer.  6.48. What is the ratio of the Emissions (1000 metric ton of CO2 equivalent) in 2008 in Italy to that in Mexico?
Provide a succinct answer. 1.21. What is the ratio of the Emissions (1000 metric ton of CO2 equivalent) of 1990 in Italy to that in Netherlands?
Make the answer very short. 1.24. What is the ratio of the Emissions (1000 metric ton of CO2 equivalent) of 2000 in Italy to that in Netherlands?
Give a very brief answer. 1.42. What is the ratio of the Emissions (1000 metric ton of CO2 equivalent) in 2005 in Italy to that in Netherlands?
Offer a terse response. 1.35. What is the ratio of the Emissions (1000 metric ton of CO2 equivalent) of 2008 in Italy to that in Netherlands?
Keep it short and to the point. 0.79. What is the ratio of the Emissions (1000 metric ton of CO2 equivalent) in 1990 in Japan to that in Korea (Republic)?
Offer a very short reply. 9.3. What is the ratio of the Emissions (1000 metric ton of CO2 equivalent) of 2000 in Japan to that in Korea (Republic)?
Your response must be concise. 0.65. What is the ratio of the Emissions (1000 metric ton of CO2 equivalent) in 2005 in Japan to that in Korea (Republic)?
Provide a short and direct response. 1.39. What is the ratio of the Emissions (1000 metric ton of CO2 equivalent) in 2008 in Japan to that in Korea (Republic)?
Make the answer very short. 2.59. What is the ratio of the Emissions (1000 metric ton of CO2 equivalent) of 1990 in Japan to that in Lithuania?
Make the answer very short. 13.41. What is the ratio of the Emissions (1000 metric ton of CO2 equivalent) in 2000 in Japan to that in Lithuania?
Give a very brief answer. 3.39. What is the ratio of the Emissions (1000 metric ton of CO2 equivalent) of 2005 in Japan to that in Lithuania?
Make the answer very short. 1.57. What is the ratio of the Emissions (1000 metric ton of CO2 equivalent) of 2008 in Japan to that in Lithuania?
Provide a succinct answer. 1.2. What is the ratio of the Emissions (1000 metric ton of CO2 equivalent) of 1990 in Japan to that in Mexico?
Ensure brevity in your answer.  9.89. What is the ratio of the Emissions (1000 metric ton of CO2 equivalent) of 2000 in Japan to that in Mexico?
Make the answer very short. 3.61. What is the ratio of the Emissions (1000 metric ton of CO2 equivalent) of 2005 in Japan to that in Mexico?
Keep it short and to the point. 2.69. What is the ratio of the Emissions (1000 metric ton of CO2 equivalent) of 2008 in Japan to that in Mexico?
Provide a short and direct response. 2.54. What is the ratio of the Emissions (1000 metric ton of CO2 equivalent) of 1990 in Japan to that in Netherlands?
Your answer should be very brief. 1.79. What is the ratio of the Emissions (1000 metric ton of CO2 equivalent) of 2000 in Japan to that in Netherlands?
Your response must be concise. 0.78. What is the ratio of the Emissions (1000 metric ton of CO2 equivalent) of 2005 in Japan to that in Netherlands?
Your response must be concise. 0.56. What is the ratio of the Emissions (1000 metric ton of CO2 equivalent) in 2008 in Japan to that in Netherlands?
Offer a terse response. 1.65. What is the ratio of the Emissions (1000 metric ton of CO2 equivalent) in 1990 in Korea (Republic) to that in Lithuania?
Ensure brevity in your answer.  1.44. What is the ratio of the Emissions (1000 metric ton of CO2 equivalent) of 2000 in Korea (Republic) to that in Lithuania?
Offer a terse response. 5.2. What is the ratio of the Emissions (1000 metric ton of CO2 equivalent) of 2005 in Korea (Republic) to that in Lithuania?
Your answer should be compact. 1.12. What is the ratio of the Emissions (1000 metric ton of CO2 equivalent) in 2008 in Korea (Republic) to that in Lithuania?
Offer a terse response. 0.47. What is the ratio of the Emissions (1000 metric ton of CO2 equivalent) in 1990 in Korea (Republic) to that in Mexico?
Provide a short and direct response. 1.06. What is the ratio of the Emissions (1000 metric ton of CO2 equivalent) of 2000 in Korea (Republic) to that in Mexico?
Offer a very short reply. 5.54. What is the ratio of the Emissions (1000 metric ton of CO2 equivalent) of 2005 in Korea (Republic) to that in Mexico?
Your answer should be compact. 1.93. What is the ratio of the Emissions (1000 metric ton of CO2 equivalent) of 2008 in Korea (Republic) to that in Mexico?
Keep it short and to the point. 0.98. What is the ratio of the Emissions (1000 metric ton of CO2 equivalent) in 1990 in Korea (Republic) to that in Netherlands?
Ensure brevity in your answer.  0.19. What is the ratio of the Emissions (1000 metric ton of CO2 equivalent) in 2000 in Korea (Republic) to that in Netherlands?
Your answer should be compact. 1.19. What is the ratio of the Emissions (1000 metric ton of CO2 equivalent) of 2005 in Korea (Republic) to that in Netherlands?
Give a very brief answer. 0.4. What is the ratio of the Emissions (1000 metric ton of CO2 equivalent) in 2008 in Korea (Republic) to that in Netherlands?
Give a very brief answer. 0.64. What is the ratio of the Emissions (1000 metric ton of CO2 equivalent) of 1990 in Lithuania to that in Mexico?
Provide a short and direct response. 0.74. What is the ratio of the Emissions (1000 metric ton of CO2 equivalent) of 2000 in Lithuania to that in Mexico?
Make the answer very short. 1.07. What is the ratio of the Emissions (1000 metric ton of CO2 equivalent) of 2005 in Lithuania to that in Mexico?
Make the answer very short. 1.72. What is the ratio of the Emissions (1000 metric ton of CO2 equivalent) of 2008 in Lithuania to that in Mexico?
Offer a very short reply. 2.11. What is the ratio of the Emissions (1000 metric ton of CO2 equivalent) of 1990 in Lithuania to that in Netherlands?
Offer a very short reply. 0.13. What is the ratio of the Emissions (1000 metric ton of CO2 equivalent) of 2000 in Lithuania to that in Netherlands?
Give a very brief answer. 0.23. What is the ratio of the Emissions (1000 metric ton of CO2 equivalent) in 2005 in Lithuania to that in Netherlands?
Provide a short and direct response. 0.36. What is the ratio of the Emissions (1000 metric ton of CO2 equivalent) of 2008 in Lithuania to that in Netherlands?
Your response must be concise. 1.37. What is the ratio of the Emissions (1000 metric ton of CO2 equivalent) in 1990 in Mexico to that in Netherlands?
Give a very brief answer. 0.18. What is the ratio of the Emissions (1000 metric ton of CO2 equivalent) of 2000 in Mexico to that in Netherlands?
Provide a short and direct response. 0.21. What is the ratio of the Emissions (1000 metric ton of CO2 equivalent) of 2005 in Mexico to that in Netherlands?
Ensure brevity in your answer.  0.21. What is the ratio of the Emissions (1000 metric ton of CO2 equivalent) of 2008 in Mexico to that in Netherlands?
Your answer should be compact. 0.65. What is the difference between the highest and the second highest Emissions (1000 metric ton of CO2 equivalent) in 1990?
Provide a succinct answer. 3189.6. What is the difference between the highest and the second highest Emissions (1000 metric ton of CO2 equivalent) in 2000?
Make the answer very short. 1337.4. What is the difference between the highest and the second highest Emissions (1000 metric ton of CO2 equivalent) of 2005?
Give a very brief answer. 1961.3. What is the difference between the highest and the second highest Emissions (1000 metric ton of CO2 equivalent) of 2008?
Ensure brevity in your answer.  493. What is the difference between the highest and the lowest Emissions (1000 metric ton of CO2 equivalent) of 1990?
Your answer should be very brief. 9574.2. What is the difference between the highest and the lowest Emissions (1000 metric ton of CO2 equivalent) in 2000?
Your response must be concise. 6912.8. What is the difference between the highest and the lowest Emissions (1000 metric ton of CO2 equivalent) in 2005?
Your answer should be very brief. 6380.1. What is the difference between the highest and the lowest Emissions (1000 metric ton of CO2 equivalent) of 2008?
Make the answer very short. 1779.1. 